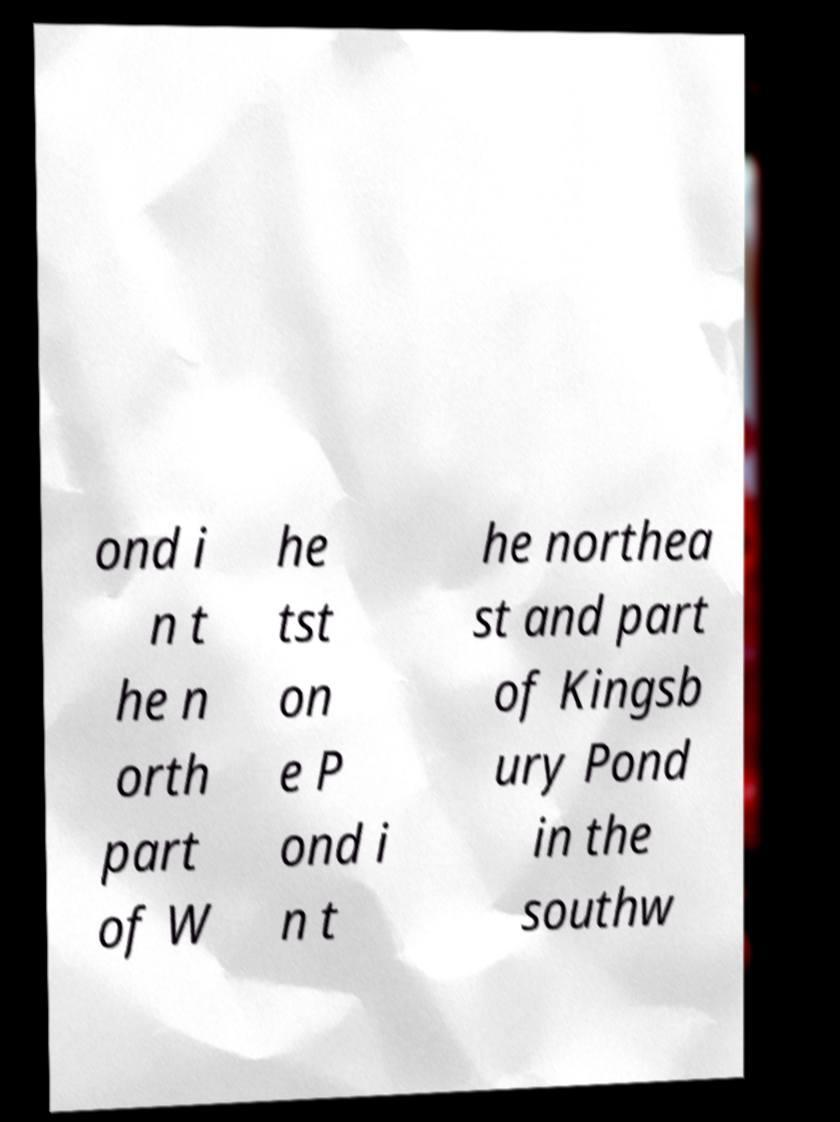Can you read and provide the text displayed in the image?This photo seems to have some interesting text. Can you extract and type it out for me? ond i n t he n orth part of W he tst on e P ond i n t he northea st and part of Kingsb ury Pond in the southw 